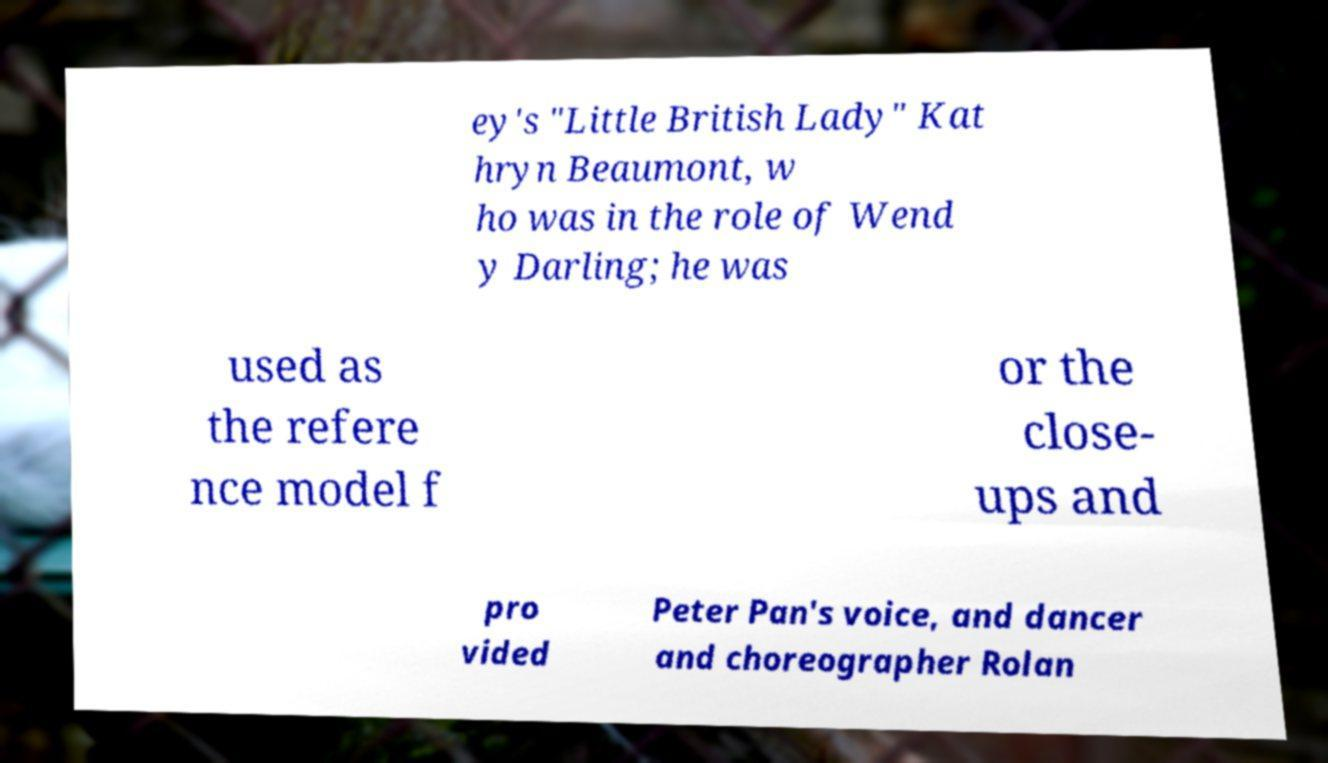Can you read and provide the text displayed in the image?This photo seems to have some interesting text. Can you extract and type it out for me? ey's "Little British Lady" Kat hryn Beaumont, w ho was in the role of Wend y Darling; he was used as the refere nce model f or the close- ups and pro vided Peter Pan's voice, and dancer and choreographer Rolan 